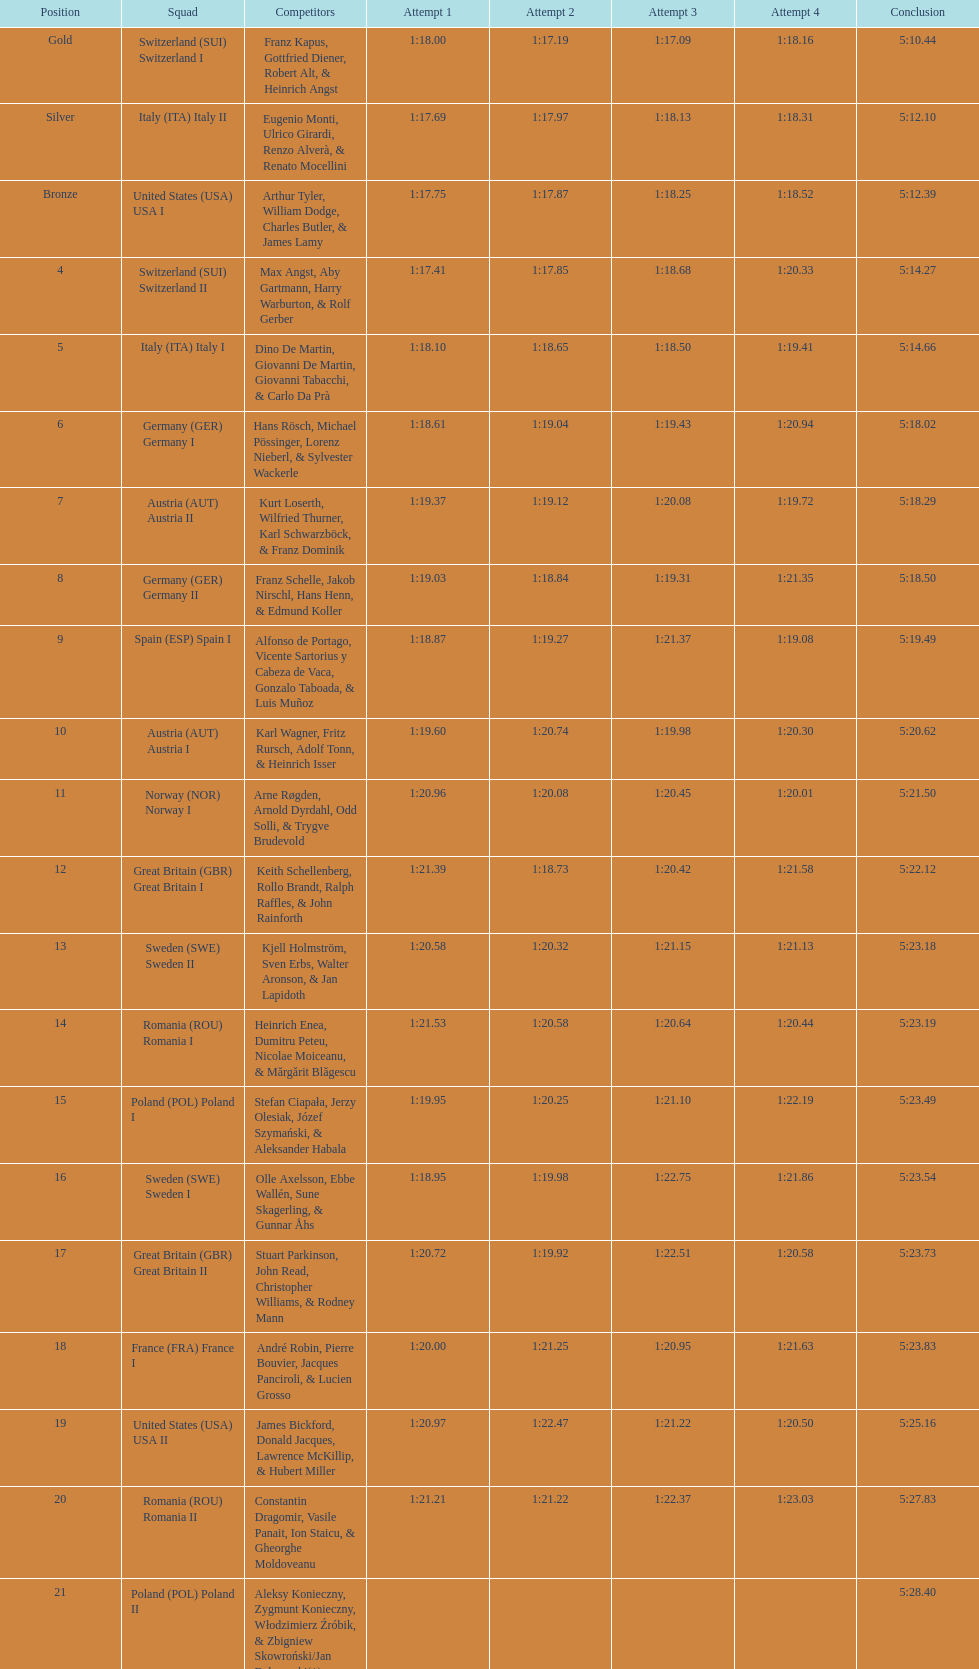What team came in second to last place? Romania. 